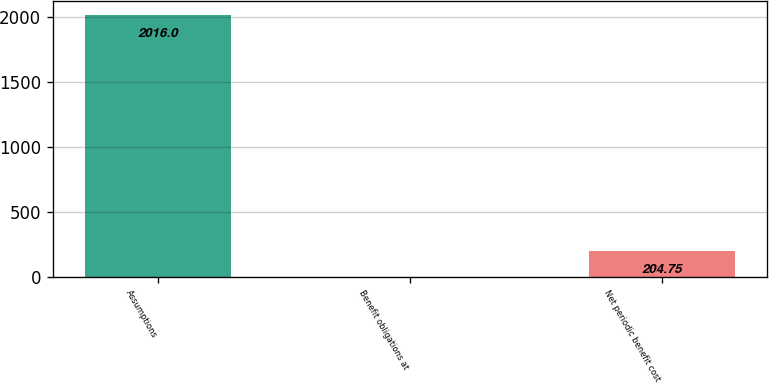Convert chart to OTSL. <chart><loc_0><loc_0><loc_500><loc_500><bar_chart><fcel>Assumptions<fcel>Benefit obligations at<fcel>Net periodic benefit cost<nl><fcel>2016<fcel>3.5<fcel>204.75<nl></chart> 